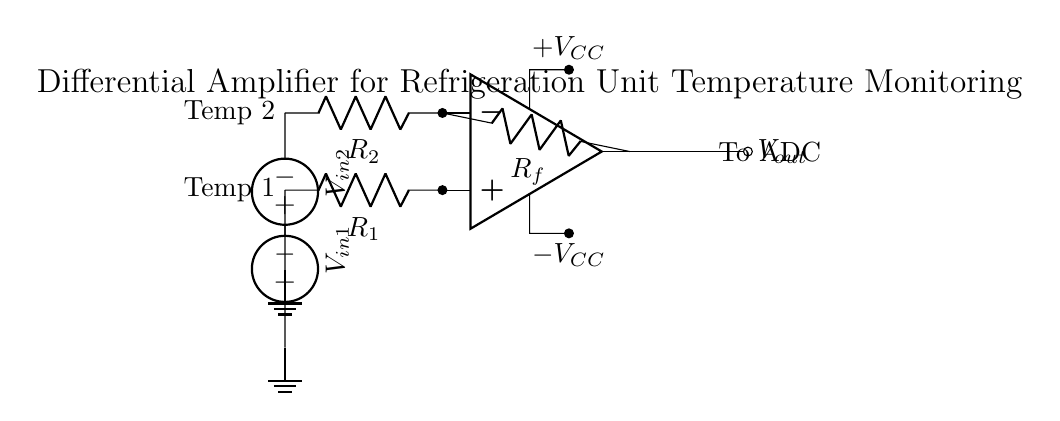What is the function of the feedback resistor? The feedback resistor, labeled as R_f, is used to set the gain of the differential amplifier. By providing feedback, it helps to stabilize the output and controls the amplification of the difference between the two input voltages.
Answer: To set gain What are the input voltages in the circuit? The circuit has two input voltages, V_in1 and V_in2, which are connected to the non-inverting and inverting terminals of the op-amp, respectively. They represent the temperatures from two different sensors being monitored.
Answer: V_in1, V_in2 How many resistors are present in the circuit? There are three resistors in the circuit: R_1 and R_2 as input resistors, and R_f as the feedback resistor. These resistors play crucial roles in determining the input impedance and gain of the amplifier.
Answer: Three What does the output voltage indicate? The output voltage, V_out, represents the amplified difference between the two input voltages, allowing for monitoring and analysis of the temperature differences captured by the sensors.
Answer: Amplified temperature difference What is the power supply voltage type in the circuit? The power supply to the operational amplifier is indicated as +V_CC and -V_CC, meaning that it receives dual polarity supply voltages. This is typical for operational amplifiers to allow for full signal swing output.
Answer: Dual polarity How do the sensors relate to the circuit? The sensors are connected to the input terminals of the differential amplifier, represented as Temp 1 and Temp 2. They provide temperature readings that are converted into voltage levels (V_in1 and V_in2) for processing by the amplifier.
Answer: They provide temperature voltage inputs 